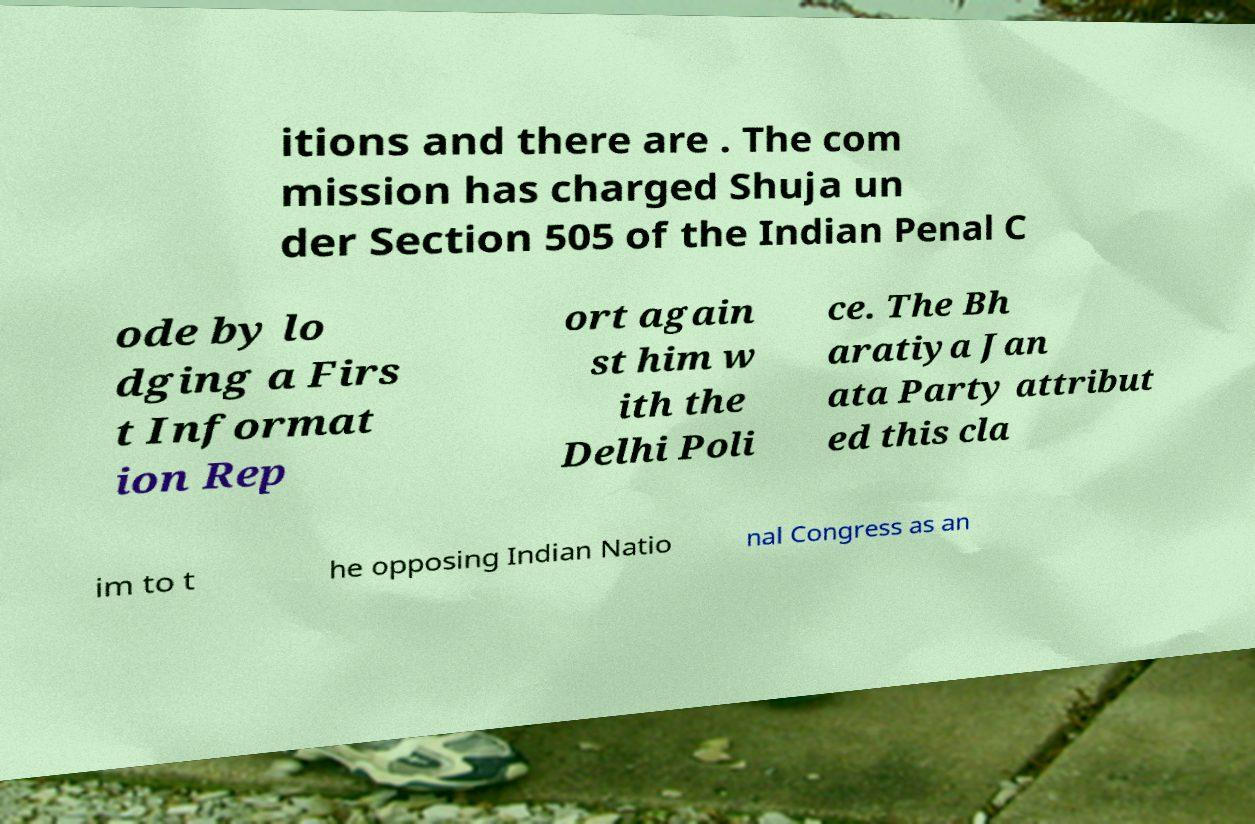Please identify and transcribe the text found in this image. itions and there are . The com mission has charged Shuja un der Section 505 of the Indian Penal C ode by lo dging a Firs t Informat ion Rep ort again st him w ith the Delhi Poli ce. The Bh aratiya Jan ata Party attribut ed this cla im to t he opposing Indian Natio nal Congress as an 